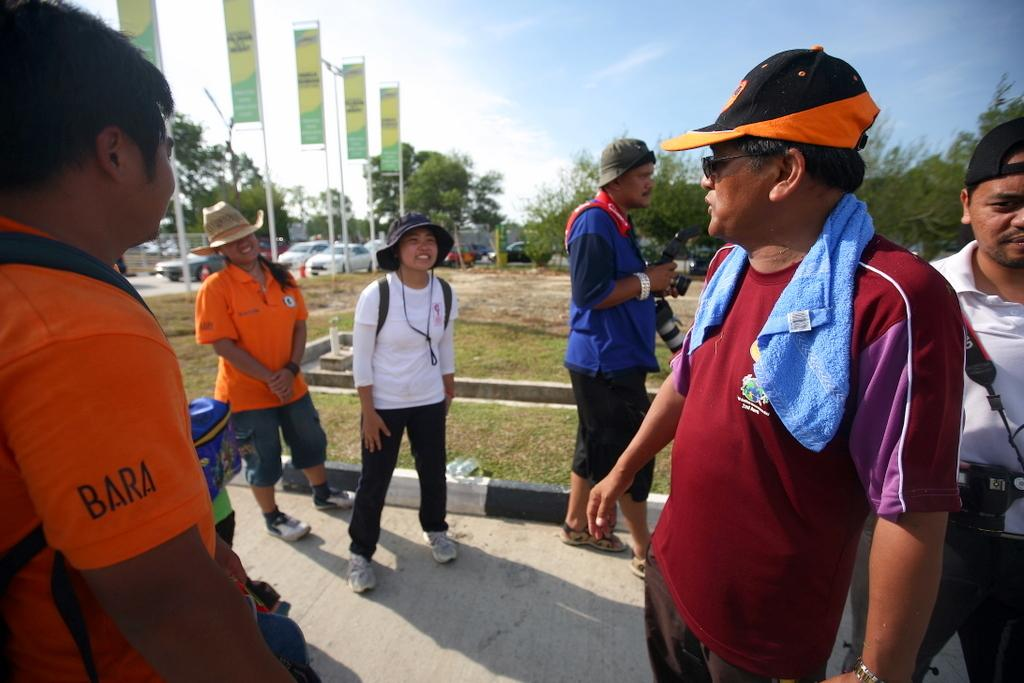What are the people in the image doing? The persons in the image are standing on the road. What can be seen at the top of the image? The sky is visible at the top of the image. What type of signage is present in the image? Hoarding boards are present in the image. What else is visible in the image besides the people and hoarding boards? Vehicles are visible in the image. What type of pies are being sold on the hoarding boards in the image? There is no mention of pies or any food items being sold on the hoarding boards in the image. 